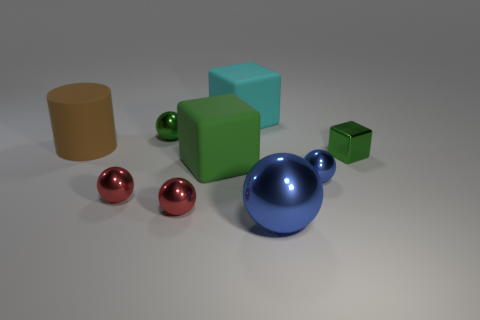Subtract all tiny red balls. How many balls are left? 3 Subtract all green balls. How many balls are left? 4 Subtract 1 green spheres. How many objects are left? 8 Subtract all cylinders. How many objects are left? 8 Subtract 3 blocks. How many blocks are left? 0 Subtract all yellow cylinders. Subtract all green blocks. How many cylinders are left? 1 Subtract all red cylinders. How many gray cubes are left? 0 Subtract all brown rubber cubes. Subtract all big green rubber things. How many objects are left? 8 Add 2 small objects. How many small objects are left? 7 Add 1 tiny purple cubes. How many tiny purple cubes exist? 1 